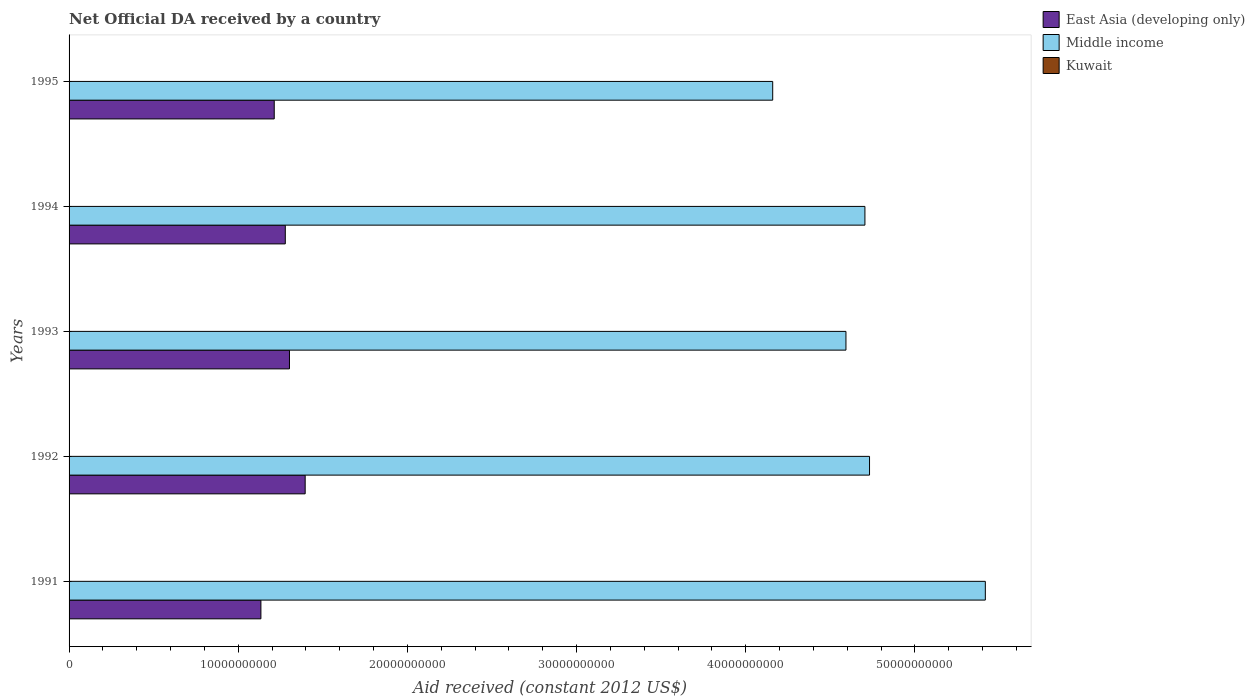How many different coloured bars are there?
Offer a terse response. 3. How many groups of bars are there?
Offer a very short reply. 5. How many bars are there on the 4th tick from the top?
Keep it short and to the point. 3. In how many cases, is the number of bars for a given year not equal to the number of legend labels?
Offer a very short reply. 0. What is the net official development assistance aid received in East Asia (developing only) in 1995?
Your answer should be very brief. 1.21e+1. Across all years, what is the maximum net official development assistance aid received in East Asia (developing only)?
Your answer should be very brief. 1.40e+1. Across all years, what is the minimum net official development assistance aid received in East Asia (developing only)?
Ensure brevity in your answer.  1.13e+1. In which year was the net official development assistance aid received in Middle income maximum?
Provide a short and direct response. 1991. In which year was the net official development assistance aid received in East Asia (developing only) minimum?
Give a very brief answer. 1991. What is the total net official development assistance aid received in Kuwait in the graph?
Offer a terse response. 4.17e+07. What is the difference between the net official development assistance aid received in Middle income in 1992 and that in 1994?
Your response must be concise. 2.73e+08. What is the difference between the net official development assistance aid received in Middle income in 1994 and the net official development assistance aid received in East Asia (developing only) in 1995?
Your answer should be very brief. 3.49e+1. What is the average net official development assistance aid received in Middle income per year?
Your answer should be compact. 4.72e+1. In the year 1995, what is the difference between the net official development assistance aid received in Middle income and net official development assistance aid received in East Asia (developing only)?
Offer a very short reply. 2.95e+1. In how many years, is the net official development assistance aid received in Kuwait greater than 4000000000 US$?
Offer a very short reply. 0. What is the ratio of the net official development assistance aid received in Kuwait in 1991 to that in 1994?
Your answer should be compact. 2.89. Is the net official development assistance aid received in Middle income in 1991 less than that in 1994?
Keep it short and to the point. No. What is the difference between the highest and the second highest net official development assistance aid received in East Asia (developing only)?
Offer a very short reply. 9.28e+08. What is the difference between the highest and the lowest net official development assistance aid received in Middle income?
Provide a short and direct response. 1.26e+1. In how many years, is the net official development assistance aid received in East Asia (developing only) greater than the average net official development assistance aid received in East Asia (developing only) taken over all years?
Give a very brief answer. 3. Is the sum of the net official development assistance aid received in East Asia (developing only) in 1993 and 1995 greater than the maximum net official development assistance aid received in Middle income across all years?
Offer a terse response. No. What does the 3rd bar from the top in 1991 represents?
Ensure brevity in your answer.  East Asia (developing only). What does the 1st bar from the bottom in 1995 represents?
Ensure brevity in your answer.  East Asia (developing only). How many bars are there?
Give a very brief answer. 15. Does the graph contain grids?
Ensure brevity in your answer.  No. What is the title of the graph?
Provide a short and direct response. Net Official DA received by a country. Does "Macao" appear as one of the legend labels in the graph?
Your answer should be very brief. No. What is the label or title of the X-axis?
Provide a succinct answer. Aid received (constant 2012 US$). What is the label or title of the Y-axis?
Give a very brief answer. Years. What is the Aid received (constant 2012 US$) in East Asia (developing only) in 1991?
Make the answer very short. 1.13e+1. What is the Aid received (constant 2012 US$) of Middle income in 1991?
Your response must be concise. 5.42e+1. What is the Aid received (constant 2012 US$) of Kuwait in 1991?
Keep it short and to the point. 1.80e+07. What is the Aid received (constant 2012 US$) of East Asia (developing only) in 1992?
Give a very brief answer. 1.40e+1. What is the Aid received (constant 2012 US$) in Middle income in 1992?
Offer a very short reply. 4.73e+1. What is the Aid received (constant 2012 US$) in Kuwait in 1992?
Give a very brief answer. 9.36e+06. What is the Aid received (constant 2012 US$) in East Asia (developing only) in 1993?
Provide a short and direct response. 1.30e+1. What is the Aid received (constant 2012 US$) of Middle income in 1993?
Your response must be concise. 4.59e+1. What is the Aid received (constant 2012 US$) of Kuwait in 1993?
Ensure brevity in your answer.  2.88e+06. What is the Aid received (constant 2012 US$) in East Asia (developing only) in 1994?
Your answer should be very brief. 1.28e+1. What is the Aid received (constant 2012 US$) in Middle income in 1994?
Make the answer very short. 4.70e+1. What is the Aid received (constant 2012 US$) in Kuwait in 1994?
Make the answer very short. 6.22e+06. What is the Aid received (constant 2012 US$) in East Asia (developing only) in 1995?
Make the answer very short. 1.21e+1. What is the Aid received (constant 2012 US$) of Middle income in 1995?
Keep it short and to the point. 4.16e+1. What is the Aid received (constant 2012 US$) in Kuwait in 1995?
Your answer should be compact. 5.29e+06. Across all years, what is the maximum Aid received (constant 2012 US$) in East Asia (developing only)?
Provide a short and direct response. 1.40e+1. Across all years, what is the maximum Aid received (constant 2012 US$) of Middle income?
Your response must be concise. 5.42e+1. Across all years, what is the maximum Aid received (constant 2012 US$) in Kuwait?
Your response must be concise. 1.80e+07. Across all years, what is the minimum Aid received (constant 2012 US$) of East Asia (developing only)?
Give a very brief answer. 1.13e+1. Across all years, what is the minimum Aid received (constant 2012 US$) of Middle income?
Offer a terse response. 4.16e+1. Across all years, what is the minimum Aid received (constant 2012 US$) of Kuwait?
Keep it short and to the point. 2.88e+06. What is the total Aid received (constant 2012 US$) of East Asia (developing only) in the graph?
Make the answer very short. 6.32e+1. What is the total Aid received (constant 2012 US$) in Middle income in the graph?
Make the answer very short. 2.36e+11. What is the total Aid received (constant 2012 US$) in Kuwait in the graph?
Give a very brief answer. 4.17e+07. What is the difference between the Aid received (constant 2012 US$) in East Asia (developing only) in 1991 and that in 1992?
Provide a short and direct response. -2.62e+09. What is the difference between the Aid received (constant 2012 US$) of Middle income in 1991 and that in 1992?
Ensure brevity in your answer.  6.84e+09. What is the difference between the Aid received (constant 2012 US$) of Kuwait in 1991 and that in 1992?
Make the answer very short. 8.59e+06. What is the difference between the Aid received (constant 2012 US$) of East Asia (developing only) in 1991 and that in 1993?
Give a very brief answer. -1.69e+09. What is the difference between the Aid received (constant 2012 US$) of Middle income in 1991 and that in 1993?
Provide a short and direct response. 8.24e+09. What is the difference between the Aid received (constant 2012 US$) in Kuwait in 1991 and that in 1993?
Your response must be concise. 1.51e+07. What is the difference between the Aid received (constant 2012 US$) of East Asia (developing only) in 1991 and that in 1994?
Your response must be concise. -1.44e+09. What is the difference between the Aid received (constant 2012 US$) of Middle income in 1991 and that in 1994?
Your answer should be compact. 7.12e+09. What is the difference between the Aid received (constant 2012 US$) of Kuwait in 1991 and that in 1994?
Ensure brevity in your answer.  1.17e+07. What is the difference between the Aid received (constant 2012 US$) of East Asia (developing only) in 1991 and that in 1995?
Offer a terse response. -7.88e+08. What is the difference between the Aid received (constant 2012 US$) of Middle income in 1991 and that in 1995?
Offer a terse response. 1.26e+1. What is the difference between the Aid received (constant 2012 US$) of Kuwait in 1991 and that in 1995?
Offer a very short reply. 1.27e+07. What is the difference between the Aid received (constant 2012 US$) of East Asia (developing only) in 1992 and that in 1993?
Ensure brevity in your answer.  9.28e+08. What is the difference between the Aid received (constant 2012 US$) of Middle income in 1992 and that in 1993?
Your response must be concise. 1.39e+09. What is the difference between the Aid received (constant 2012 US$) of Kuwait in 1992 and that in 1993?
Offer a terse response. 6.48e+06. What is the difference between the Aid received (constant 2012 US$) of East Asia (developing only) in 1992 and that in 1994?
Offer a very short reply. 1.17e+09. What is the difference between the Aid received (constant 2012 US$) in Middle income in 1992 and that in 1994?
Keep it short and to the point. 2.73e+08. What is the difference between the Aid received (constant 2012 US$) in Kuwait in 1992 and that in 1994?
Your answer should be compact. 3.14e+06. What is the difference between the Aid received (constant 2012 US$) of East Asia (developing only) in 1992 and that in 1995?
Ensure brevity in your answer.  1.83e+09. What is the difference between the Aid received (constant 2012 US$) of Middle income in 1992 and that in 1995?
Offer a very short reply. 5.72e+09. What is the difference between the Aid received (constant 2012 US$) of Kuwait in 1992 and that in 1995?
Offer a very short reply. 4.07e+06. What is the difference between the Aid received (constant 2012 US$) in East Asia (developing only) in 1993 and that in 1994?
Your answer should be compact. 2.47e+08. What is the difference between the Aid received (constant 2012 US$) in Middle income in 1993 and that in 1994?
Offer a terse response. -1.12e+09. What is the difference between the Aid received (constant 2012 US$) of Kuwait in 1993 and that in 1994?
Your answer should be compact. -3.34e+06. What is the difference between the Aid received (constant 2012 US$) in East Asia (developing only) in 1993 and that in 1995?
Provide a succinct answer. 9.01e+08. What is the difference between the Aid received (constant 2012 US$) of Middle income in 1993 and that in 1995?
Offer a terse response. 4.33e+09. What is the difference between the Aid received (constant 2012 US$) of Kuwait in 1993 and that in 1995?
Make the answer very short. -2.41e+06. What is the difference between the Aid received (constant 2012 US$) of East Asia (developing only) in 1994 and that in 1995?
Offer a terse response. 6.54e+08. What is the difference between the Aid received (constant 2012 US$) in Middle income in 1994 and that in 1995?
Offer a terse response. 5.45e+09. What is the difference between the Aid received (constant 2012 US$) in Kuwait in 1994 and that in 1995?
Your answer should be compact. 9.30e+05. What is the difference between the Aid received (constant 2012 US$) of East Asia (developing only) in 1991 and the Aid received (constant 2012 US$) of Middle income in 1992?
Your response must be concise. -3.60e+1. What is the difference between the Aid received (constant 2012 US$) of East Asia (developing only) in 1991 and the Aid received (constant 2012 US$) of Kuwait in 1992?
Provide a succinct answer. 1.13e+1. What is the difference between the Aid received (constant 2012 US$) in Middle income in 1991 and the Aid received (constant 2012 US$) in Kuwait in 1992?
Offer a very short reply. 5.42e+1. What is the difference between the Aid received (constant 2012 US$) of East Asia (developing only) in 1991 and the Aid received (constant 2012 US$) of Middle income in 1993?
Make the answer very short. -3.46e+1. What is the difference between the Aid received (constant 2012 US$) in East Asia (developing only) in 1991 and the Aid received (constant 2012 US$) in Kuwait in 1993?
Ensure brevity in your answer.  1.13e+1. What is the difference between the Aid received (constant 2012 US$) in Middle income in 1991 and the Aid received (constant 2012 US$) in Kuwait in 1993?
Your response must be concise. 5.42e+1. What is the difference between the Aid received (constant 2012 US$) of East Asia (developing only) in 1991 and the Aid received (constant 2012 US$) of Middle income in 1994?
Your answer should be very brief. -3.57e+1. What is the difference between the Aid received (constant 2012 US$) in East Asia (developing only) in 1991 and the Aid received (constant 2012 US$) in Kuwait in 1994?
Keep it short and to the point. 1.13e+1. What is the difference between the Aid received (constant 2012 US$) of Middle income in 1991 and the Aid received (constant 2012 US$) of Kuwait in 1994?
Your answer should be compact. 5.42e+1. What is the difference between the Aid received (constant 2012 US$) of East Asia (developing only) in 1991 and the Aid received (constant 2012 US$) of Middle income in 1995?
Offer a very short reply. -3.03e+1. What is the difference between the Aid received (constant 2012 US$) in East Asia (developing only) in 1991 and the Aid received (constant 2012 US$) in Kuwait in 1995?
Your response must be concise. 1.13e+1. What is the difference between the Aid received (constant 2012 US$) in Middle income in 1991 and the Aid received (constant 2012 US$) in Kuwait in 1995?
Offer a very short reply. 5.42e+1. What is the difference between the Aid received (constant 2012 US$) of East Asia (developing only) in 1992 and the Aid received (constant 2012 US$) of Middle income in 1993?
Make the answer very short. -3.20e+1. What is the difference between the Aid received (constant 2012 US$) in East Asia (developing only) in 1992 and the Aid received (constant 2012 US$) in Kuwait in 1993?
Provide a short and direct response. 1.40e+1. What is the difference between the Aid received (constant 2012 US$) in Middle income in 1992 and the Aid received (constant 2012 US$) in Kuwait in 1993?
Ensure brevity in your answer.  4.73e+1. What is the difference between the Aid received (constant 2012 US$) in East Asia (developing only) in 1992 and the Aid received (constant 2012 US$) in Middle income in 1994?
Offer a very short reply. -3.31e+1. What is the difference between the Aid received (constant 2012 US$) of East Asia (developing only) in 1992 and the Aid received (constant 2012 US$) of Kuwait in 1994?
Offer a very short reply. 1.40e+1. What is the difference between the Aid received (constant 2012 US$) of Middle income in 1992 and the Aid received (constant 2012 US$) of Kuwait in 1994?
Make the answer very short. 4.73e+1. What is the difference between the Aid received (constant 2012 US$) of East Asia (developing only) in 1992 and the Aid received (constant 2012 US$) of Middle income in 1995?
Offer a very short reply. -2.76e+1. What is the difference between the Aid received (constant 2012 US$) of East Asia (developing only) in 1992 and the Aid received (constant 2012 US$) of Kuwait in 1995?
Give a very brief answer. 1.40e+1. What is the difference between the Aid received (constant 2012 US$) of Middle income in 1992 and the Aid received (constant 2012 US$) of Kuwait in 1995?
Offer a terse response. 4.73e+1. What is the difference between the Aid received (constant 2012 US$) of East Asia (developing only) in 1993 and the Aid received (constant 2012 US$) of Middle income in 1994?
Make the answer very short. -3.40e+1. What is the difference between the Aid received (constant 2012 US$) in East Asia (developing only) in 1993 and the Aid received (constant 2012 US$) in Kuwait in 1994?
Your answer should be very brief. 1.30e+1. What is the difference between the Aid received (constant 2012 US$) of Middle income in 1993 and the Aid received (constant 2012 US$) of Kuwait in 1994?
Offer a terse response. 4.59e+1. What is the difference between the Aid received (constant 2012 US$) in East Asia (developing only) in 1993 and the Aid received (constant 2012 US$) in Middle income in 1995?
Offer a terse response. -2.86e+1. What is the difference between the Aid received (constant 2012 US$) of East Asia (developing only) in 1993 and the Aid received (constant 2012 US$) of Kuwait in 1995?
Offer a very short reply. 1.30e+1. What is the difference between the Aid received (constant 2012 US$) of Middle income in 1993 and the Aid received (constant 2012 US$) of Kuwait in 1995?
Ensure brevity in your answer.  4.59e+1. What is the difference between the Aid received (constant 2012 US$) of East Asia (developing only) in 1994 and the Aid received (constant 2012 US$) of Middle income in 1995?
Your response must be concise. -2.88e+1. What is the difference between the Aid received (constant 2012 US$) in East Asia (developing only) in 1994 and the Aid received (constant 2012 US$) in Kuwait in 1995?
Offer a very short reply. 1.28e+1. What is the difference between the Aid received (constant 2012 US$) in Middle income in 1994 and the Aid received (constant 2012 US$) in Kuwait in 1995?
Ensure brevity in your answer.  4.70e+1. What is the average Aid received (constant 2012 US$) of East Asia (developing only) per year?
Make the answer very short. 1.26e+1. What is the average Aid received (constant 2012 US$) in Middle income per year?
Provide a short and direct response. 4.72e+1. What is the average Aid received (constant 2012 US$) of Kuwait per year?
Provide a succinct answer. 8.34e+06. In the year 1991, what is the difference between the Aid received (constant 2012 US$) of East Asia (developing only) and Aid received (constant 2012 US$) of Middle income?
Your answer should be very brief. -4.28e+1. In the year 1991, what is the difference between the Aid received (constant 2012 US$) in East Asia (developing only) and Aid received (constant 2012 US$) in Kuwait?
Your answer should be very brief. 1.13e+1. In the year 1991, what is the difference between the Aid received (constant 2012 US$) in Middle income and Aid received (constant 2012 US$) in Kuwait?
Offer a terse response. 5.41e+1. In the year 1992, what is the difference between the Aid received (constant 2012 US$) of East Asia (developing only) and Aid received (constant 2012 US$) of Middle income?
Keep it short and to the point. -3.34e+1. In the year 1992, what is the difference between the Aid received (constant 2012 US$) in East Asia (developing only) and Aid received (constant 2012 US$) in Kuwait?
Your response must be concise. 1.39e+1. In the year 1992, what is the difference between the Aid received (constant 2012 US$) in Middle income and Aid received (constant 2012 US$) in Kuwait?
Make the answer very short. 4.73e+1. In the year 1993, what is the difference between the Aid received (constant 2012 US$) in East Asia (developing only) and Aid received (constant 2012 US$) in Middle income?
Your response must be concise. -3.29e+1. In the year 1993, what is the difference between the Aid received (constant 2012 US$) in East Asia (developing only) and Aid received (constant 2012 US$) in Kuwait?
Provide a short and direct response. 1.30e+1. In the year 1993, what is the difference between the Aid received (constant 2012 US$) in Middle income and Aid received (constant 2012 US$) in Kuwait?
Provide a succinct answer. 4.59e+1. In the year 1994, what is the difference between the Aid received (constant 2012 US$) in East Asia (developing only) and Aid received (constant 2012 US$) in Middle income?
Provide a short and direct response. -3.43e+1. In the year 1994, what is the difference between the Aid received (constant 2012 US$) of East Asia (developing only) and Aid received (constant 2012 US$) of Kuwait?
Make the answer very short. 1.28e+1. In the year 1994, what is the difference between the Aid received (constant 2012 US$) in Middle income and Aid received (constant 2012 US$) in Kuwait?
Provide a short and direct response. 4.70e+1. In the year 1995, what is the difference between the Aid received (constant 2012 US$) of East Asia (developing only) and Aid received (constant 2012 US$) of Middle income?
Give a very brief answer. -2.95e+1. In the year 1995, what is the difference between the Aid received (constant 2012 US$) in East Asia (developing only) and Aid received (constant 2012 US$) in Kuwait?
Your answer should be compact. 1.21e+1. In the year 1995, what is the difference between the Aid received (constant 2012 US$) in Middle income and Aid received (constant 2012 US$) in Kuwait?
Keep it short and to the point. 4.16e+1. What is the ratio of the Aid received (constant 2012 US$) of East Asia (developing only) in 1991 to that in 1992?
Keep it short and to the point. 0.81. What is the ratio of the Aid received (constant 2012 US$) of Middle income in 1991 to that in 1992?
Your answer should be very brief. 1.14. What is the ratio of the Aid received (constant 2012 US$) in Kuwait in 1991 to that in 1992?
Make the answer very short. 1.92. What is the ratio of the Aid received (constant 2012 US$) of East Asia (developing only) in 1991 to that in 1993?
Provide a short and direct response. 0.87. What is the ratio of the Aid received (constant 2012 US$) in Middle income in 1991 to that in 1993?
Your response must be concise. 1.18. What is the ratio of the Aid received (constant 2012 US$) in Kuwait in 1991 to that in 1993?
Provide a succinct answer. 6.23. What is the ratio of the Aid received (constant 2012 US$) of East Asia (developing only) in 1991 to that in 1994?
Your response must be concise. 0.89. What is the ratio of the Aid received (constant 2012 US$) in Middle income in 1991 to that in 1994?
Provide a succinct answer. 1.15. What is the ratio of the Aid received (constant 2012 US$) of Kuwait in 1991 to that in 1994?
Provide a short and direct response. 2.89. What is the ratio of the Aid received (constant 2012 US$) of East Asia (developing only) in 1991 to that in 1995?
Provide a succinct answer. 0.94. What is the ratio of the Aid received (constant 2012 US$) in Middle income in 1991 to that in 1995?
Your answer should be compact. 1.3. What is the ratio of the Aid received (constant 2012 US$) in Kuwait in 1991 to that in 1995?
Your answer should be very brief. 3.39. What is the ratio of the Aid received (constant 2012 US$) of East Asia (developing only) in 1992 to that in 1993?
Offer a very short reply. 1.07. What is the ratio of the Aid received (constant 2012 US$) in Middle income in 1992 to that in 1993?
Offer a very short reply. 1.03. What is the ratio of the Aid received (constant 2012 US$) of Kuwait in 1992 to that in 1993?
Keep it short and to the point. 3.25. What is the ratio of the Aid received (constant 2012 US$) of East Asia (developing only) in 1992 to that in 1994?
Provide a succinct answer. 1.09. What is the ratio of the Aid received (constant 2012 US$) in Middle income in 1992 to that in 1994?
Keep it short and to the point. 1.01. What is the ratio of the Aid received (constant 2012 US$) in Kuwait in 1992 to that in 1994?
Offer a terse response. 1.5. What is the ratio of the Aid received (constant 2012 US$) of East Asia (developing only) in 1992 to that in 1995?
Provide a short and direct response. 1.15. What is the ratio of the Aid received (constant 2012 US$) in Middle income in 1992 to that in 1995?
Keep it short and to the point. 1.14. What is the ratio of the Aid received (constant 2012 US$) in Kuwait in 1992 to that in 1995?
Your response must be concise. 1.77. What is the ratio of the Aid received (constant 2012 US$) in East Asia (developing only) in 1993 to that in 1994?
Give a very brief answer. 1.02. What is the ratio of the Aid received (constant 2012 US$) in Middle income in 1993 to that in 1994?
Provide a short and direct response. 0.98. What is the ratio of the Aid received (constant 2012 US$) in Kuwait in 1993 to that in 1994?
Your answer should be very brief. 0.46. What is the ratio of the Aid received (constant 2012 US$) in East Asia (developing only) in 1993 to that in 1995?
Make the answer very short. 1.07. What is the ratio of the Aid received (constant 2012 US$) of Middle income in 1993 to that in 1995?
Your answer should be very brief. 1.1. What is the ratio of the Aid received (constant 2012 US$) of Kuwait in 1993 to that in 1995?
Provide a succinct answer. 0.54. What is the ratio of the Aid received (constant 2012 US$) of East Asia (developing only) in 1994 to that in 1995?
Keep it short and to the point. 1.05. What is the ratio of the Aid received (constant 2012 US$) of Middle income in 1994 to that in 1995?
Your response must be concise. 1.13. What is the ratio of the Aid received (constant 2012 US$) in Kuwait in 1994 to that in 1995?
Your response must be concise. 1.18. What is the difference between the highest and the second highest Aid received (constant 2012 US$) in East Asia (developing only)?
Keep it short and to the point. 9.28e+08. What is the difference between the highest and the second highest Aid received (constant 2012 US$) of Middle income?
Ensure brevity in your answer.  6.84e+09. What is the difference between the highest and the second highest Aid received (constant 2012 US$) of Kuwait?
Provide a short and direct response. 8.59e+06. What is the difference between the highest and the lowest Aid received (constant 2012 US$) in East Asia (developing only)?
Provide a succinct answer. 2.62e+09. What is the difference between the highest and the lowest Aid received (constant 2012 US$) of Middle income?
Make the answer very short. 1.26e+1. What is the difference between the highest and the lowest Aid received (constant 2012 US$) in Kuwait?
Ensure brevity in your answer.  1.51e+07. 